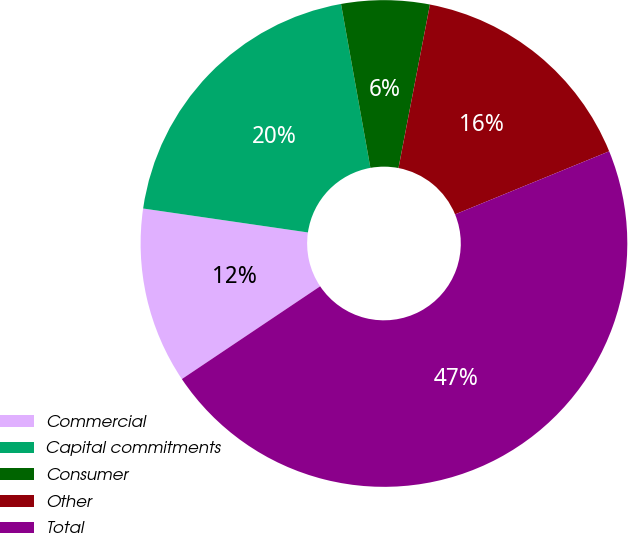Convert chart. <chart><loc_0><loc_0><loc_500><loc_500><pie_chart><fcel>Commercial<fcel>Capital commitments<fcel>Consumer<fcel>Other<fcel>Total<nl><fcel>11.7%<fcel>19.88%<fcel>5.85%<fcel>15.79%<fcel>46.78%<nl></chart> 